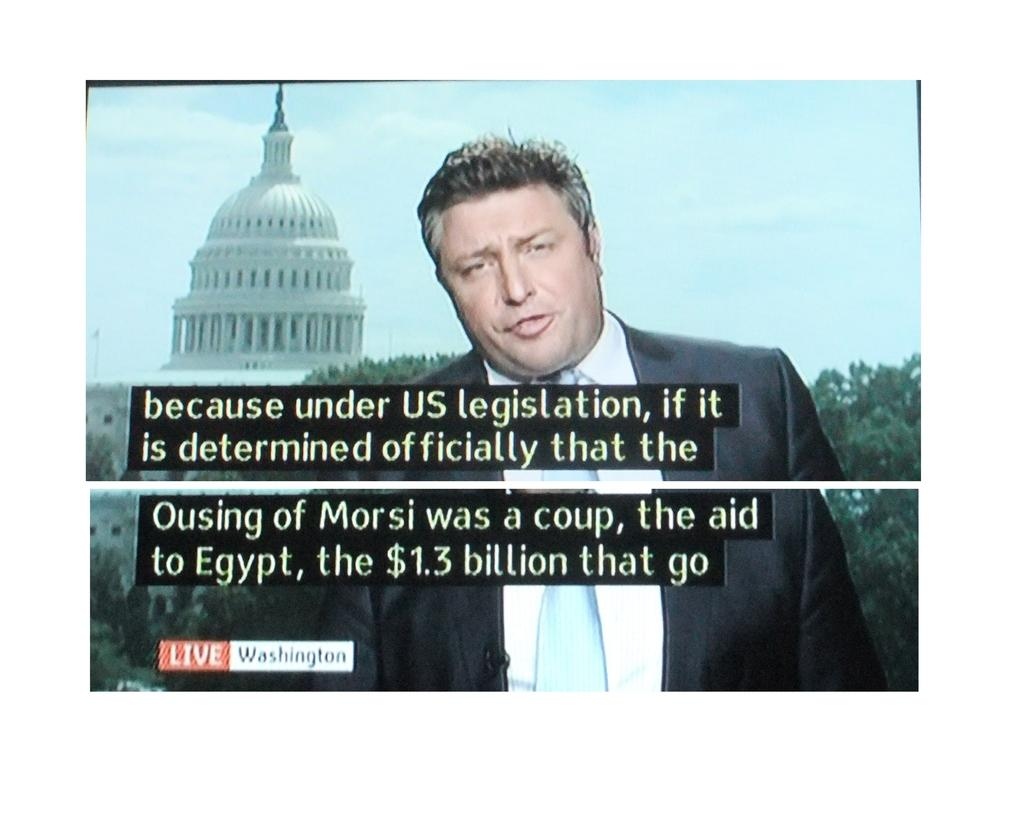Who or what is present in the image? There is a person in the image. What is the person wearing? The person is wearing a black and white dress. What can be seen in the background of the image? There is a white color fort and trees in the background. What is the color of the sky in the image? The sky is blue in color. What type of song is being sung by the person in the image? There is no indication in the image that the person is singing a song, so it cannot be determined from the picture. 